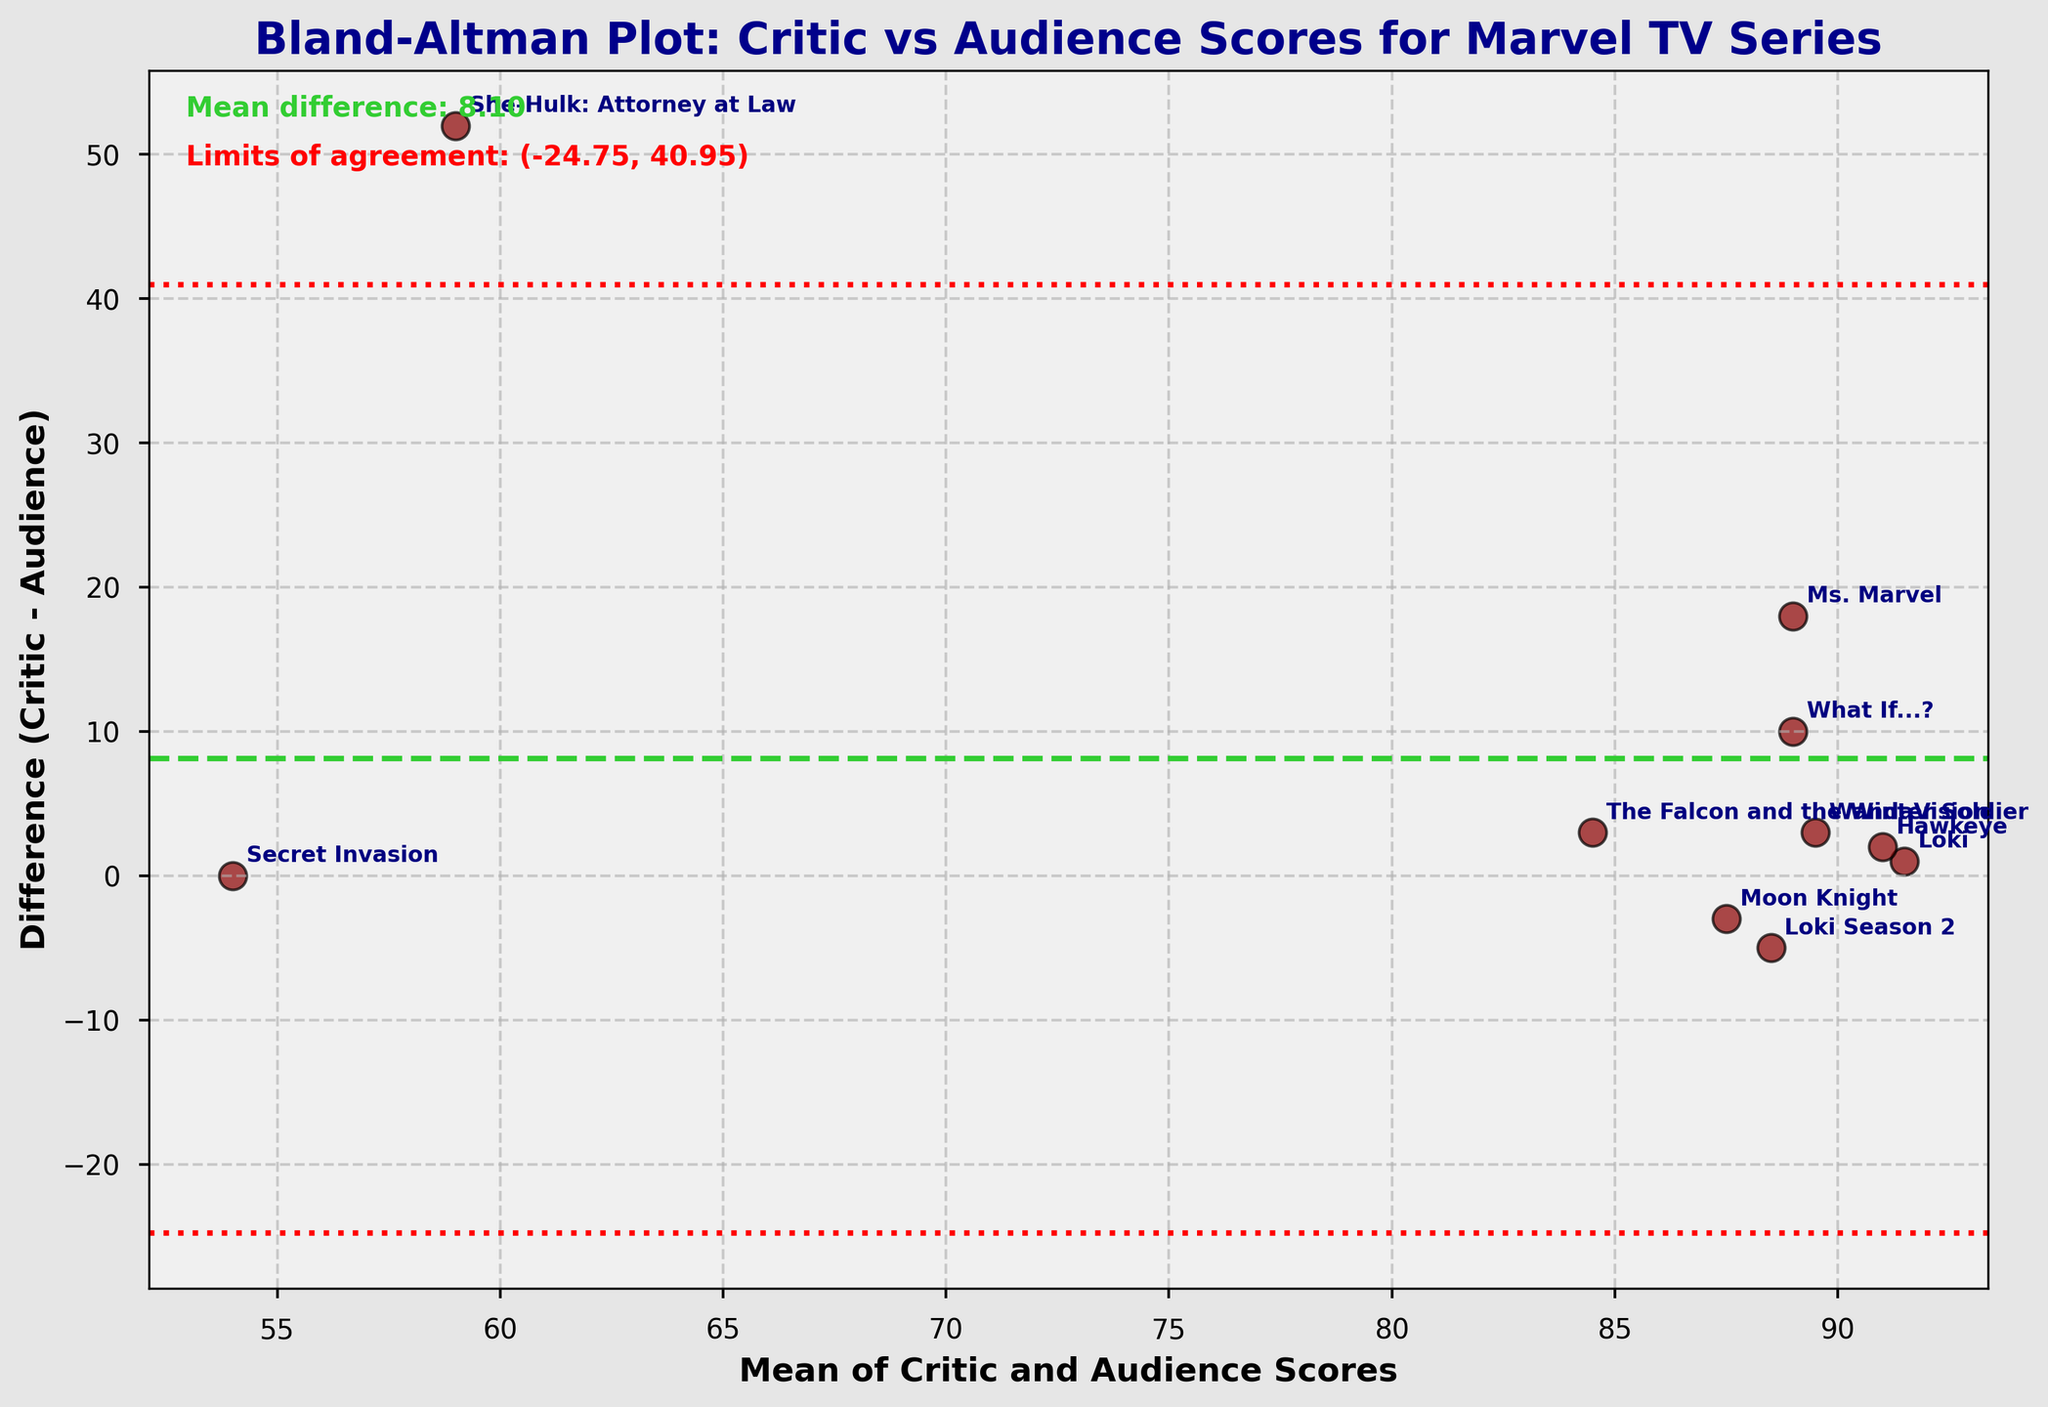what is the title of the figure? The title of the figure is prominently displayed at the top and provides a summary of what the plot represents. This helps the reader understand the context of the data being visualized.
Answer: Bland-Altman Plot: Critic vs Audience Scores for Marvel TV Series How many data points are plotted in the figure? Each series is represented as a separate data point on the plot. By counting the points or checking the series labels, you can determine the number of data points.
Answer: 10 What does a positive difference between critic and audience scores imply in this plot? A positive difference means that the critic's score is higher than the audience's score for that series. This is indicated by points above the zero-line on the y-axis.
Answer: Critic score is higher Which series has the largest difference between critic and audience scores? By looking at the scatter points farthest from the zero-line on the y-axis, we find the point with the greatest absolute difference. The labels help identify which series it corresponds to.
Answer: She-Hulk: Attorney at Law What are the mean and standard deviation of the differences? The mean difference and standard deviation are noted on the plot. The mean difference is the central green dashed line, and the limits of agreement, which use the standard deviation, are represented by red dotted lines.
Answer: Mean: 8.5, Std. Dev: 19.0118 How do the limits of agreement help in interpreting the plot? The limits of agreement, shown as red dotted lines are calculated as mean difference ± 1.96 standard deviations. They help identify whether most differences fall within a reasonable range and if there are outliers.
Answer: Indicate expected variation range Is there any series with the same critic and audience scores? Points where the difference is zero indicate that critic and audience scores are the same. Look for points on the zero-line of the y-axis.
Answer: Secret Invasion Which series has the closest agreement between critic and audience scores? Identify the point closest to the zero-line on the y-axis, indicating minimal difference between critic and audience scores. Use the series labels for identification.
Answer: Loki Are there any series that are considered outliers in this plot? Outliers are data points that fall outside the limits of agreement lines (red dotted lines). Any points beyond these lines are notable as outliers.
Answer: She-Hulk: Attorney at Law What might a mean difference of 8.5 suggest about critic and audience scores overall? A mean difference of 8.5 indicates that, on average, critic scores are consistently higher than audience scores by this value, suggesting a potential systematic bias or difference in perception between critics and audience.
Answer: Critics score higher 